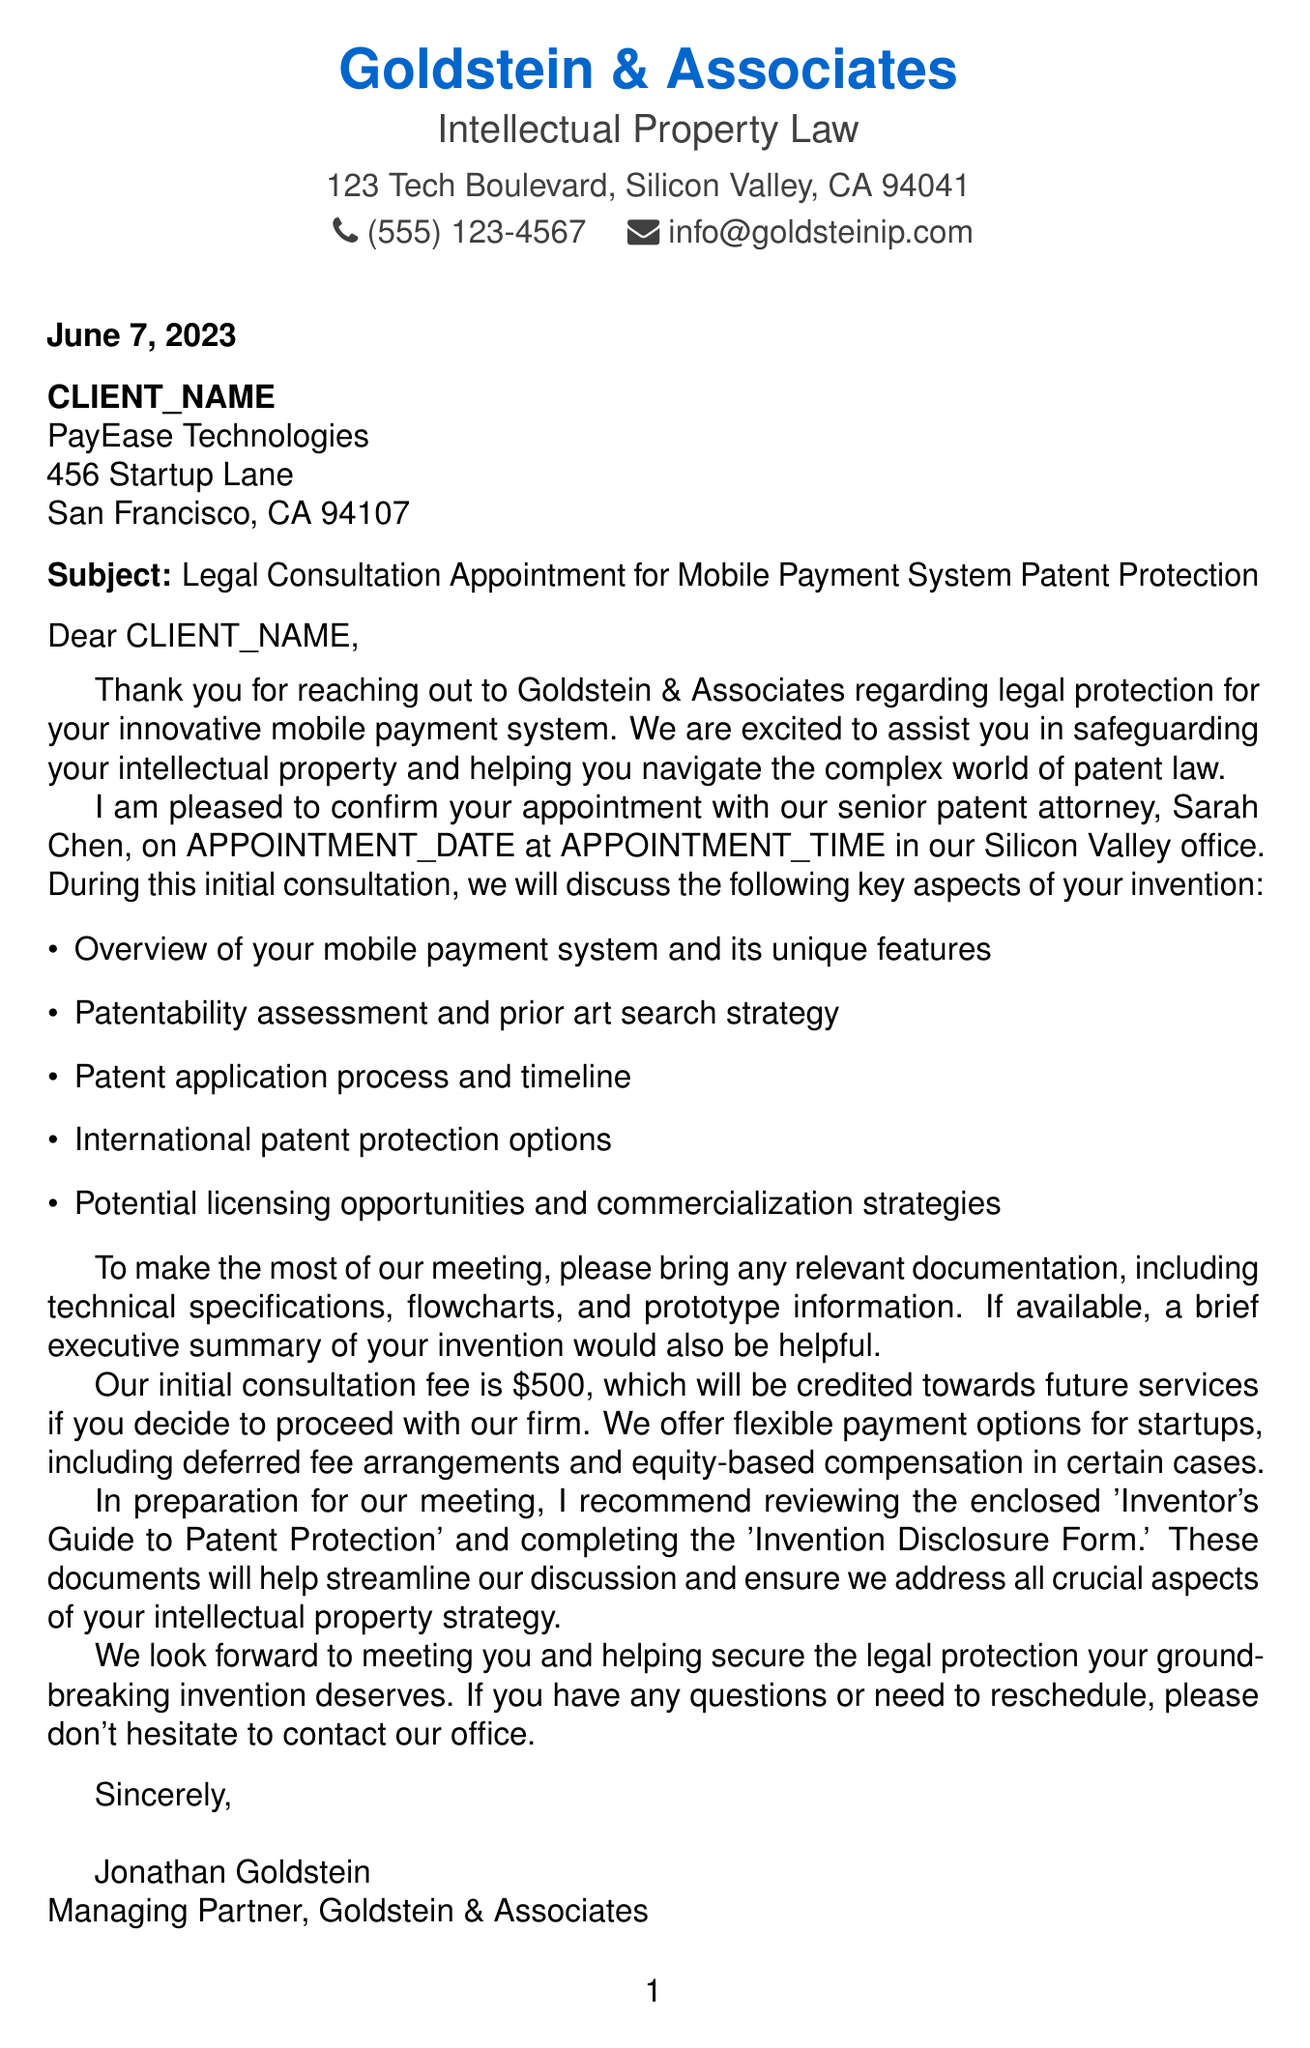What is the name of the law firm? The law firm's name is mentioned in the header of the document as the entity providing legal services.
Answer: Goldstein & Associates Who is the recipient of the letter? The recipient details are specified in the document, including their name and company.
Answer: {{CLIENT_NAME}} What is the subject of the letter? The subject line provides a concise summary of the purpose of the letter.
Answer: Legal Consultation Appointment for Mobile Payment System Patent Protection When is the scheduled appointment date? The date of the appointment is indicated in the letter and is a crucial detail for the recipient.
Answer: {{APPOINTMENT_DATE}} How much is the initial consultation fee? The consultation fee is outlined in the body of the letter and is a key financial detail.
Answer: $500 What is recommended to bring to the meeting? This part of the letter specifies the documentation that the recipient should prepare for the consultation.
Answer: Relevant documentation How long is the appointment duration? The document states the length of the meeting, which helps the recipient prepare accordingly.
Answer: 90 minutes What payment options are mentioned for startups? The letter outlines flexible payment arrangements available for startup clients, emphasizing the firm's support for entrepreneurs.
Answer: Deferred fee arrangements Is there a video conference option available for the meeting? The document includes details about alternative meeting formats available for the consultation.
Answer: Yes, if informed 24 hours in advance 